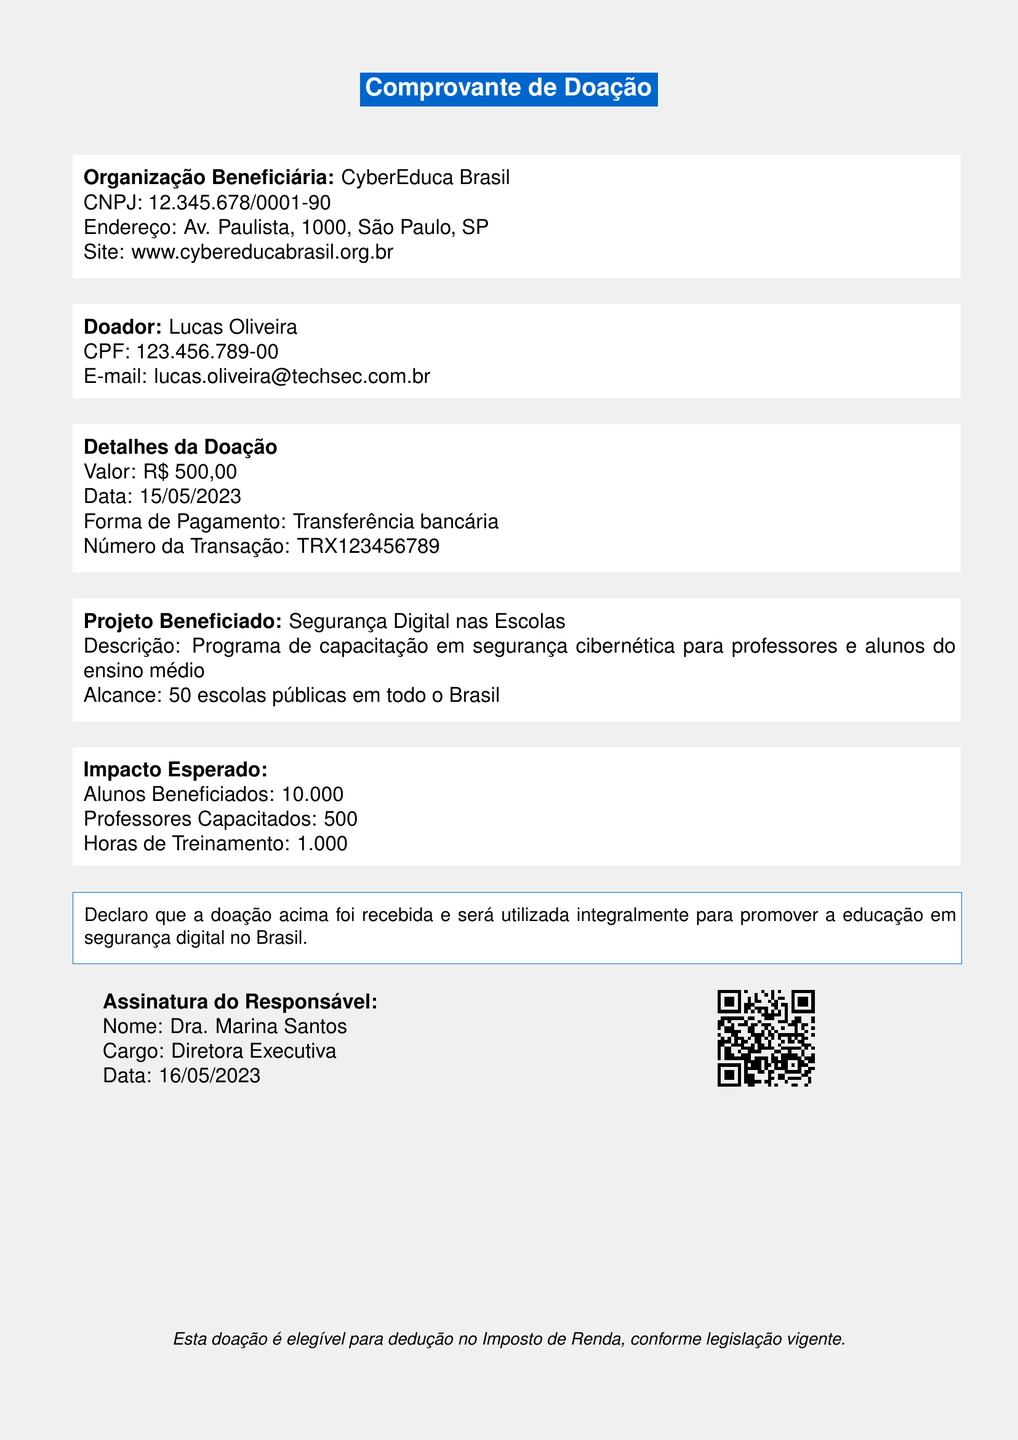Qual é o nome da organização beneficiária? O nome da organização beneficiária é mencionado na seção correspondente do documento.
Answer: CyberEduca Brasil Qual é o CNPJ da organização? O número do CNPJ é fornecido logo após o nome da organização beneficiária.
Answer: 12.345.678/0001-90 Qual é o valor da doação? O valor da doação é especificado na seção de detalhes da doação no documento.
Answer: R$ 500,00 Qual é a data da doação? A data em que a doação foi feita é apresentada na seção de detalhes da doação.
Answer: 15/05/2023 Quantas escolas serão beneficiadas pelo projeto? O número de escolas que receberão benefícios do projeto é mencionado na descrição do projeto.
Answer: 50 escolas públicas Quem é a diretora executiva da organização? O nome da responsável pela assinatura é indicado na seção de assinatura.
Answer: Dra. Marina Santos Qual é o impacto esperado em alunos beneficiados? O número de alunos beneficiados é listado na seção de impacto esperado.
Answer: 10.000 Como o doador poderá se beneficiar da doação? Os benefícios ao doador são listados de forma clara na seção apropriada do documento.
Answer: Acesso à newsletter mensal com dicas de segurança digital A doação é elegível para dedução no Imposto de Renda? A elegibilidade da doação para dedução fiscal é mencionada nas informações adicionais.
Answer: Sim Que tipo de programa é promovido pelo projeto beneficiado? A descrição do projeto beneficiado fornece informações sobre o tipo de programa que está sendo realizado.
Answer: Programa de capacitação em segurança cibernética para professores e alunos do ensino médio 